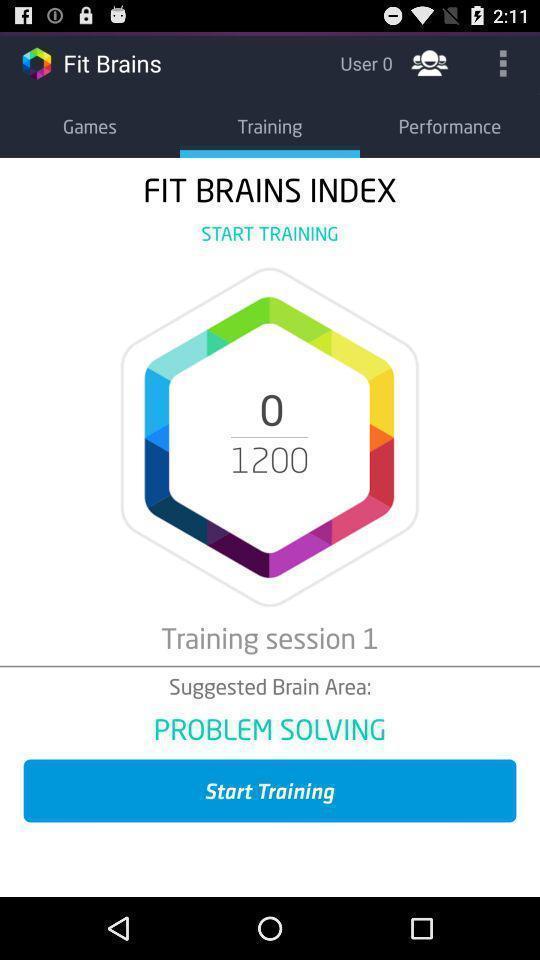Provide a description of this screenshot. Training session in the training in the fit brains. 